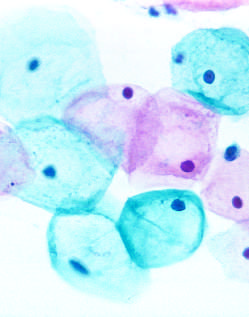re large tumor cells with pale-pink cytoplasm exfoliated?
Answer the question using a single word or phrase. No 